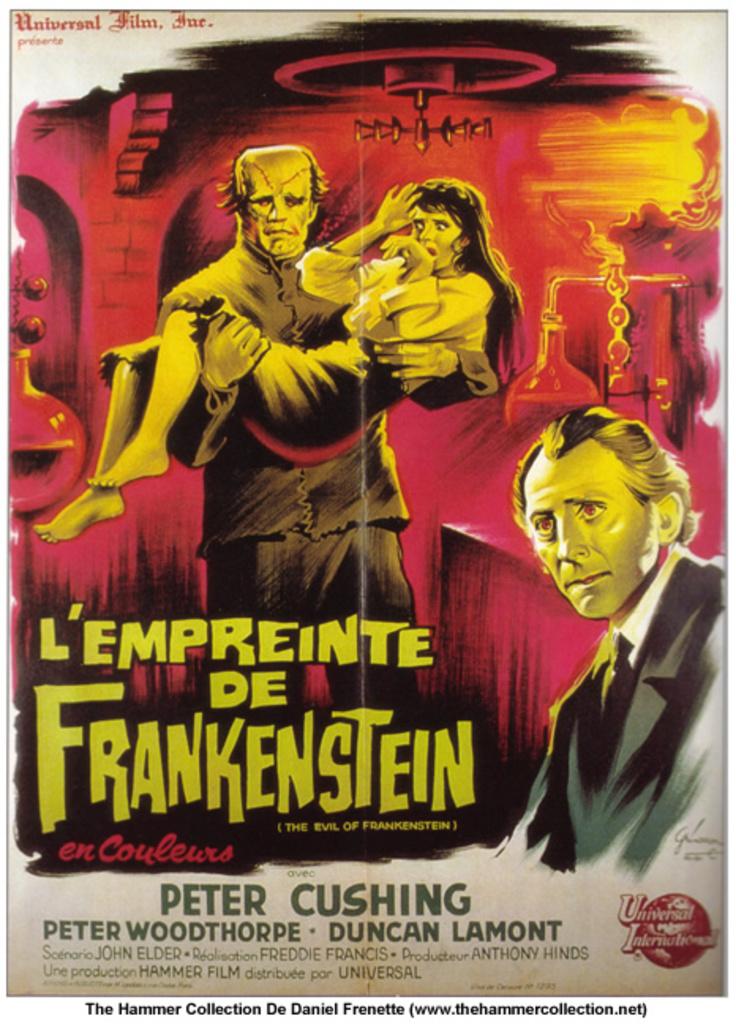What monster name is on the poster?
Your answer should be compact. Frankenstein. What´s  the first name of the author in the poster?
Give a very brief answer. Peter. 